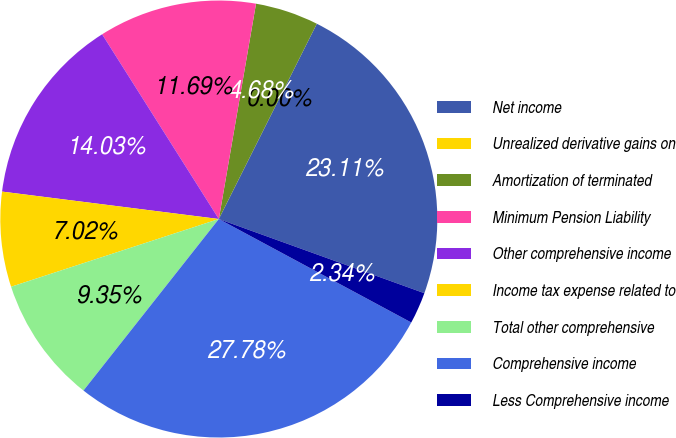<chart> <loc_0><loc_0><loc_500><loc_500><pie_chart><fcel>Net income<fcel>Unrealized derivative gains on<fcel>Amortization of terminated<fcel>Minimum Pension Liability<fcel>Other comprehensive income<fcel>Income tax expense related to<fcel>Total other comprehensive<fcel>Comprehensive income<fcel>Less Comprehensive income<nl><fcel>23.11%<fcel>0.0%<fcel>4.68%<fcel>11.69%<fcel>14.03%<fcel>7.02%<fcel>9.35%<fcel>27.78%<fcel>2.34%<nl></chart> 